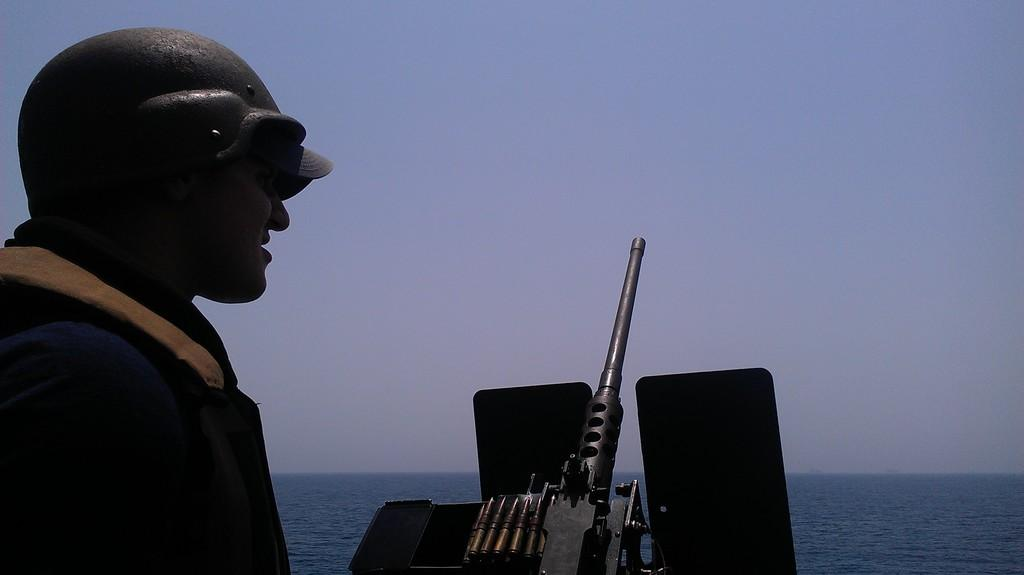What is the main subject of the image? There is a person standing in the image. What object can be seen in the image besides the person? There is a rifle in the image. What can be seen in the background of the image? Water and the sky are visible in the background of the image. What type of suit is the person wearing in the image? There is no suit visible in the image; the person is not wearing any clothing. Can you read the letter that the person is holding in the image? There is no letter present in the image; the person is not holding any object. 